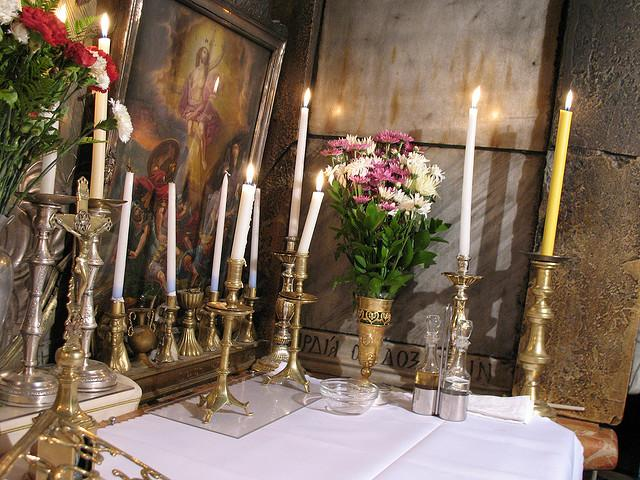What state are the candles in?

Choices:
A) dowsed
B) lit
C) fake
D) unlit lit 